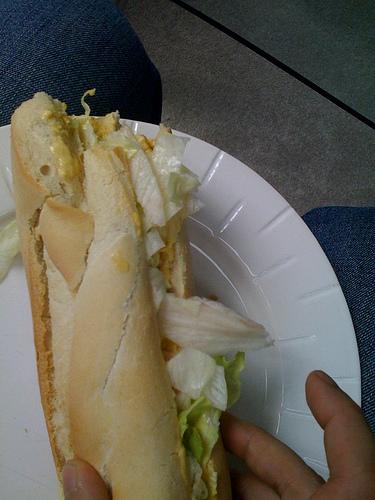What is the hot dog sitting on?
Quick response, please. Plate. Is this a paper plate?
Quick response, please. No. What color is the plate?
Quick response, please. White. What is on the plate?
Short answer required. Sandwich. What is behind the sandwich?
Keep it brief. Plate. Where is the food?
Keep it brief. On plate. What is the plate on?
Short answer required. Lap. What improvisation has this person made to their meal?
Concise answer only. Added mustard. 